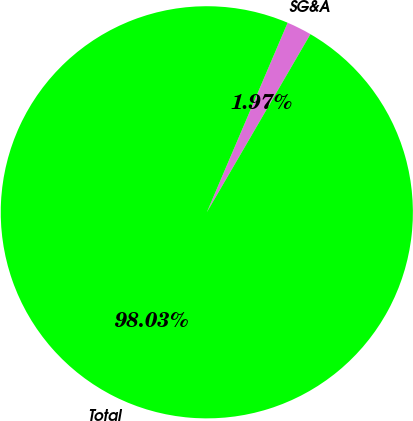Convert chart. <chart><loc_0><loc_0><loc_500><loc_500><pie_chart><fcel>SG&A<fcel>Total<nl><fcel>1.97%<fcel>98.03%<nl></chart> 